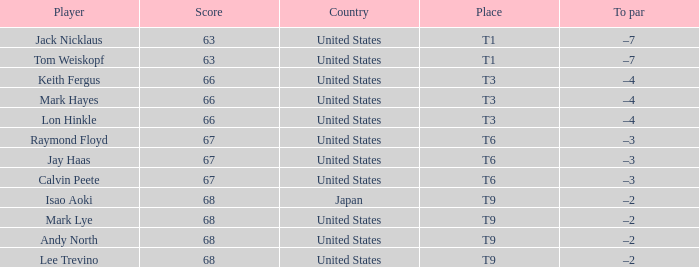Would you mind parsing the complete table? {'header': ['Player', 'Score', 'Country', 'Place', 'To par'], 'rows': [['Jack Nicklaus', '63', 'United States', 'T1', '–7'], ['Tom Weiskopf', '63', 'United States', 'T1', '–7'], ['Keith Fergus', '66', 'United States', 'T3', '–4'], ['Mark Hayes', '66', 'United States', 'T3', '–4'], ['Lon Hinkle', '66', 'United States', 'T3', '–4'], ['Raymond Floyd', '67', 'United States', 'T6', '–3'], ['Jay Haas', '67', 'United States', 'T6', '–3'], ['Calvin Peete', '67', 'United States', 'T6', '–3'], ['Isao Aoki', '68', 'Japan', 'T9', '–2'], ['Mark Lye', '68', 'United States', 'T9', '–2'], ['Andy North', '68', 'United States', 'T9', '–2'], ['Lee Trevino', '68', 'United States', 'T9', '–2']]} What is Place, when Country is "United States", and when Player is "Lee Trevino"? T9. 